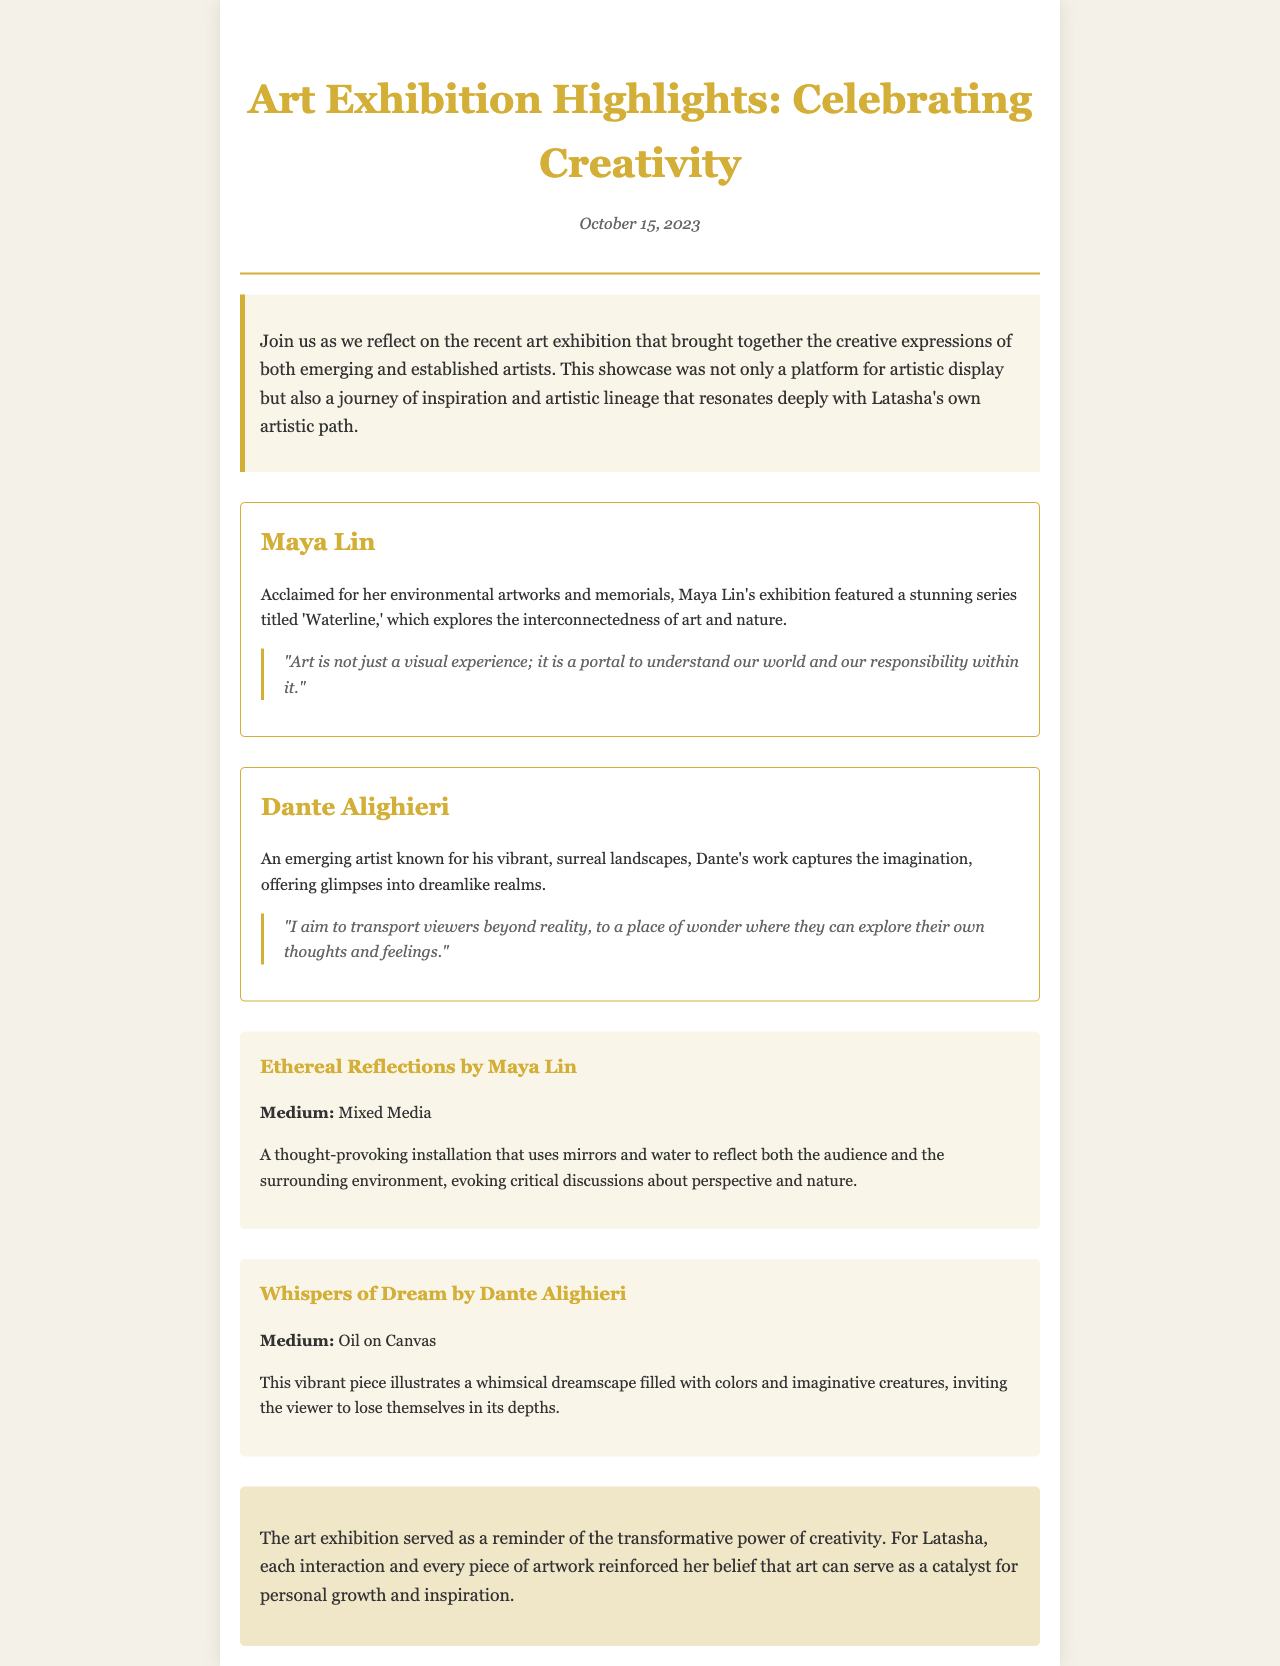What date was the art exhibition highlighted in the newsletter? The date of the art exhibition is mentioned in the header section of the document.
Answer: October 15, 2023 Who is the acclaimed artist featured in the exhibition? The document lists Maya Lin as an acclaimed artist featured in the exhibition.
Answer: Maya Lin What is the title of Maya Lin's series showcased at the exhibition? The title of Maya Lin's series is provided in the section about her work.
Answer: Waterline What is the medium used for Dante Alighieri's artwork "Whispers of Dream"? The medium for Dante Alighieri's artwork is specified in the artwork description.
Answer: Oil on Canvas What main themes does Maya Lin's artwork explore? The document describes the themes explored in Maya Lin's exhibition, particularly regarding art and nature.
Answer: Interconnectedness of art and nature What does Latasha take away from the art exhibition? The takeaway section summarizes Latasha's reflections on the exhibition and its impact.
Answer: Transformative power of creativity What type of art medium is used in Maya Lin's "Ethereal Reflections"? The document clearly states the medium used in Maya Lin's installation.
Answer: Mixed Media How does Dante Alighieri describe his artistic aim? The document includes a quote from Dante Alighieri about his artistic intentions.
Answer: Transport viewers beyond reality 